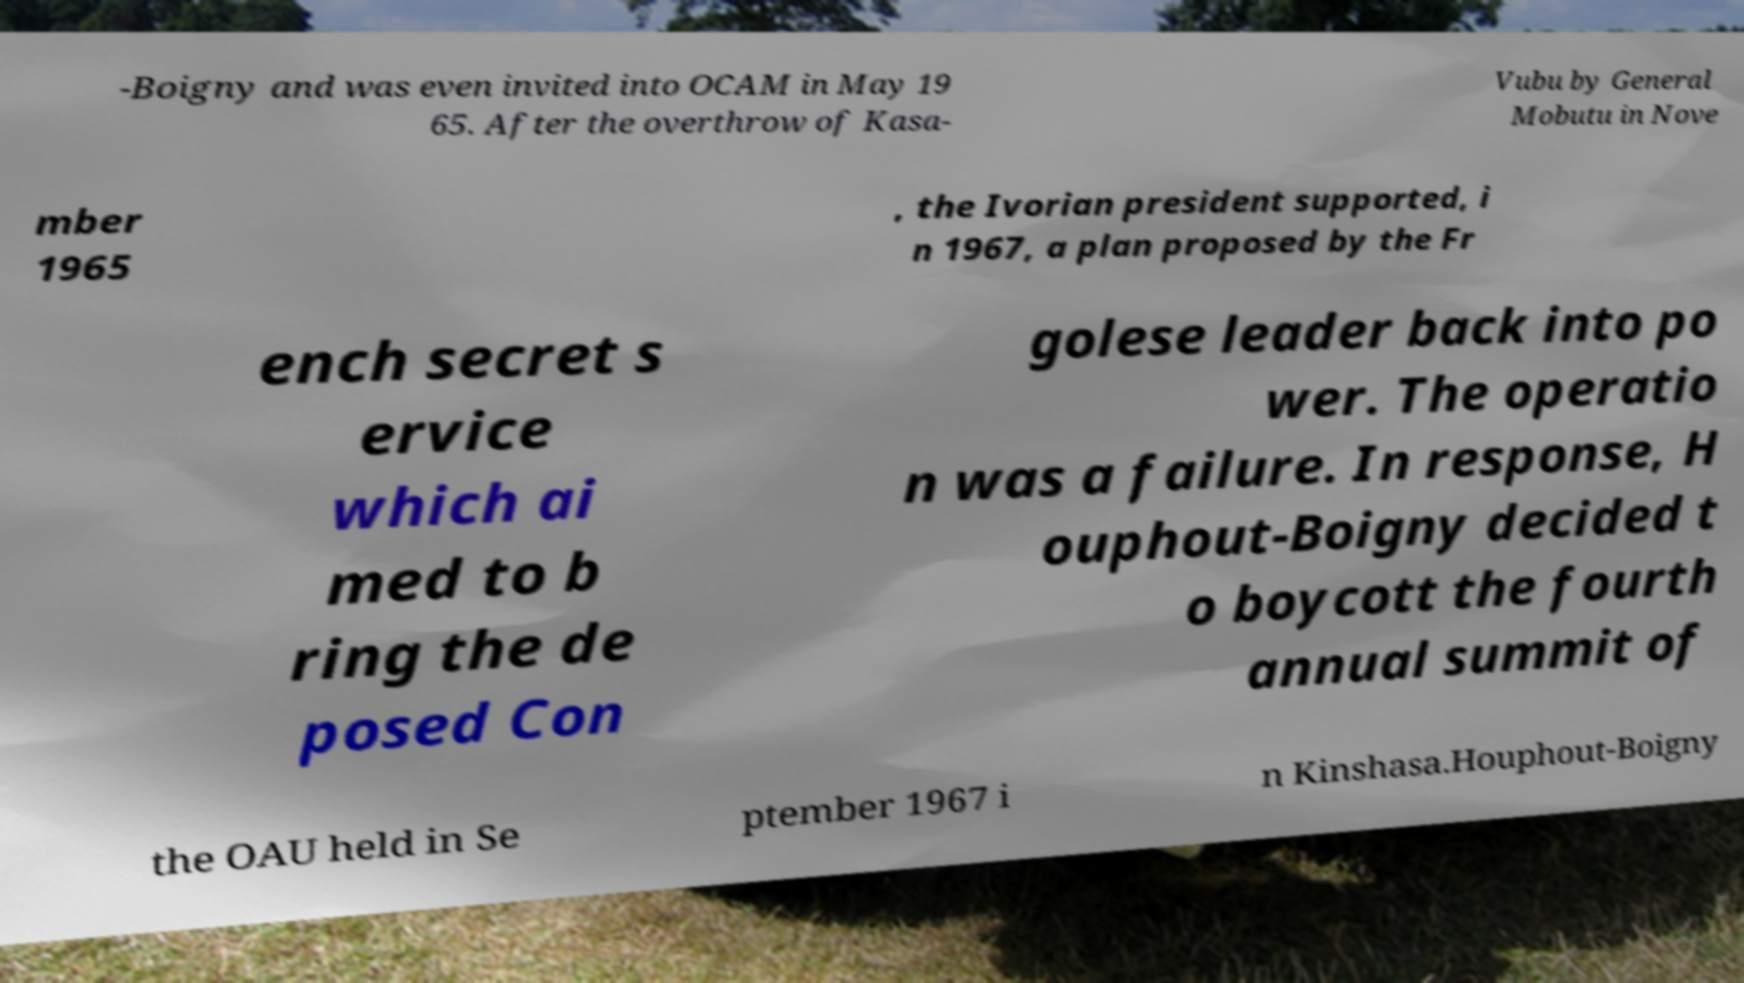For documentation purposes, I need the text within this image transcribed. Could you provide that? -Boigny and was even invited into OCAM in May 19 65. After the overthrow of Kasa- Vubu by General Mobutu in Nove mber 1965 , the Ivorian president supported, i n 1967, a plan proposed by the Fr ench secret s ervice which ai med to b ring the de posed Con golese leader back into po wer. The operatio n was a failure. In response, H ouphout-Boigny decided t o boycott the fourth annual summit of the OAU held in Se ptember 1967 i n Kinshasa.Houphout-Boigny 